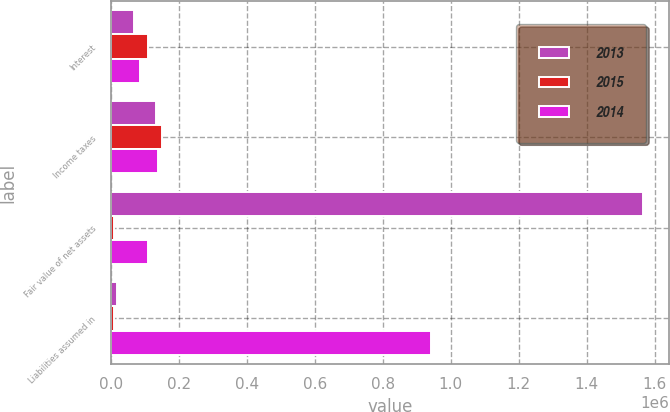Convert chart to OTSL. <chart><loc_0><loc_0><loc_500><loc_500><stacked_bar_chart><ecel><fcel>Interest<fcel>Income taxes<fcel>Fair value of net assets<fcel>Liabilities assumed in<nl><fcel>2013<fcel>67974<fcel>133283<fcel>1.56497e+06<fcel>17147<nl><fcel>2015<fcel>109451<fcel>148991<fcel>7267<fcel>7286<nl><fcel>2014<fcel>86173<fcel>137650<fcel>109451<fcel>942513<nl></chart> 